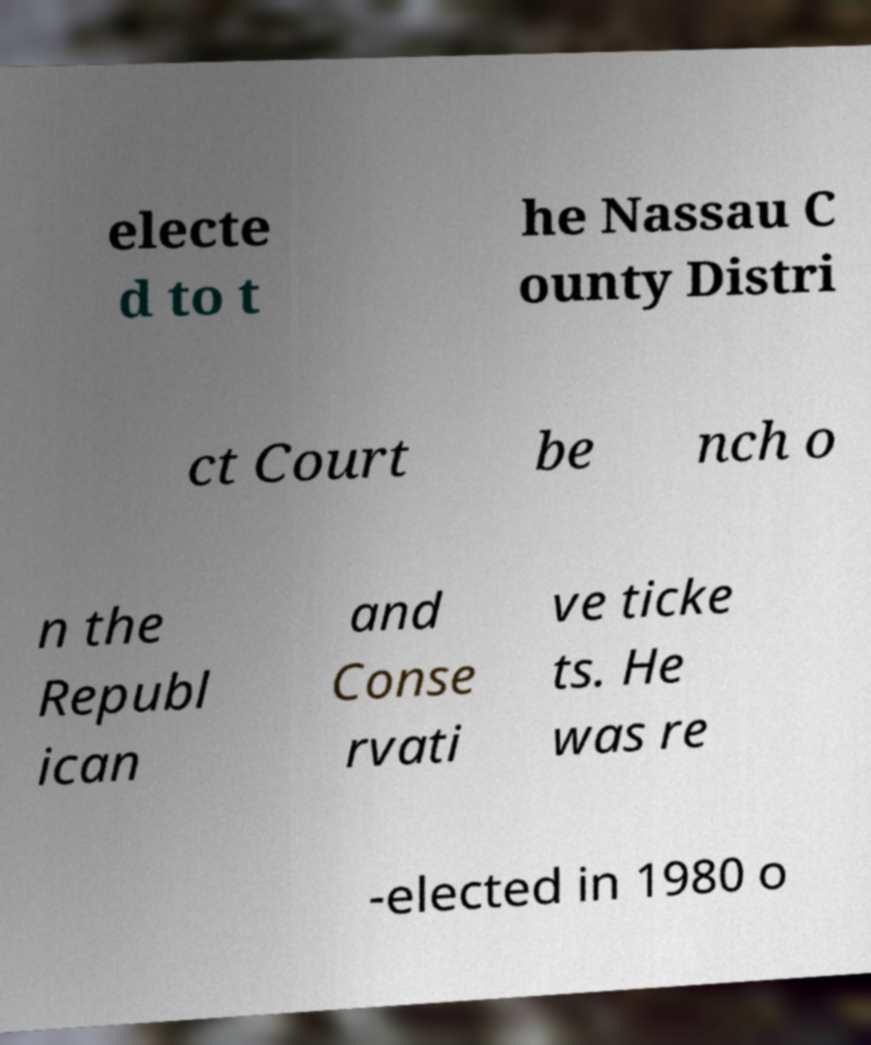Could you assist in decoding the text presented in this image and type it out clearly? electe d to t he Nassau C ounty Distri ct Court be nch o n the Republ ican and Conse rvati ve ticke ts. He was re -elected in 1980 o 